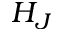Convert formula to latex. <formula><loc_0><loc_0><loc_500><loc_500>H _ { J }</formula> 